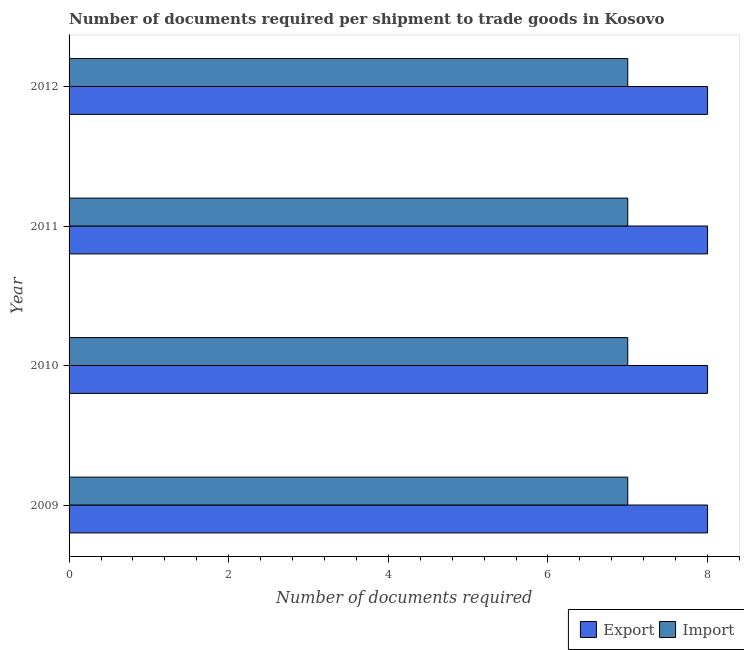How many bars are there on the 4th tick from the top?
Provide a succinct answer. 2. In how many cases, is the number of bars for a given year not equal to the number of legend labels?
Give a very brief answer. 0. What is the number of documents required to import goods in 2010?
Make the answer very short. 7. Across all years, what is the maximum number of documents required to export goods?
Ensure brevity in your answer.  8. Across all years, what is the minimum number of documents required to export goods?
Keep it short and to the point. 8. What is the total number of documents required to export goods in the graph?
Your answer should be compact. 32. What is the difference between the number of documents required to export goods in 2011 and that in 2012?
Give a very brief answer. 0. What is the difference between the number of documents required to export goods in 2010 and the number of documents required to import goods in 2012?
Offer a very short reply. 1. What is the average number of documents required to import goods per year?
Ensure brevity in your answer.  7. In the year 2012, what is the difference between the number of documents required to export goods and number of documents required to import goods?
Offer a very short reply. 1. What is the difference between the highest and the second highest number of documents required to import goods?
Your answer should be compact. 0. What is the difference between the highest and the lowest number of documents required to import goods?
Offer a terse response. 0. In how many years, is the number of documents required to import goods greater than the average number of documents required to import goods taken over all years?
Ensure brevity in your answer.  0. Is the sum of the number of documents required to import goods in 2011 and 2012 greater than the maximum number of documents required to export goods across all years?
Give a very brief answer. Yes. What does the 1st bar from the top in 2010 represents?
Your response must be concise. Import. What does the 2nd bar from the bottom in 2009 represents?
Provide a short and direct response. Import. How many bars are there?
Your response must be concise. 8. Are all the bars in the graph horizontal?
Provide a succinct answer. Yes. Does the graph contain any zero values?
Offer a very short reply. No. Does the graph contain grids?
Your answer should be compact. No. How many legend labels are there?
Keep it short and to the point. 2. How are the legend labels stacked?
Offer a terse response. Horizontal. What is the title of the graph?
Ensure brevity in your answer.  Number of documents required per shipment to trade goods in Kosovo. What is the label or title of the X-axis?
Provide a succinct answer. Number of documents required. What is the label or title of the Y-axis?
Your response must be concise. Year. What is the Number of documents required in Export in 2010?
Offer a very short reply. 8. What is the Number of documents required in Export in 2011?
Make the answer very short. 8. What is the Number of documents required of Import in 2012?
Provide a succinct answer. 7. What is the difference between the Number of documents required of Import in 2009 and that in 2011?
Your response must be concise. 0. What is the difference between the Number of documents required in Export in 2010 and that in 2011?
Keep it short and to the point. 0. What is the difference between the Number of documents required in Import in 2010 and that in 2011?
Your answer should be compact. 0. What is the difference between the Number of documents required of Export in 2011 and that in 2012?
Ensure brevity in your answer.  0. What is the difference between the Number of documents required of Export in 2009 and the Number of documents required of Import in 2010?
Provide a short and direct response. 1. What is the difference between the Number of documents required of Export in 2009 and the Number of documents required of Import in 2012?
Give a very brief answer. 1. What is the difference between the Number of documents required of Export in 2010 and the Number of documents required of Import in 2012?
Provide a succinct answer. 1. What is the difference between the Number of documents required of Export in 2011 and the Number of documents required of Import in 2012?
Keep it short and to the point. 1. What is the average Number of documents required of Export per year?
Your answer should be compact. 8. What is the average Number of documents required in Import per year?
Your answer should be very brief. 7. In the year 2011, what is the difference between the Number of documents required of Export and Number of documents required of Import?
Provide a short and direct response. 1. What is the ratio of the Number of documents required in Export in 2009 to that in 2010?
Offer a very short reply. 1. What is the ratio of the Number of documents required in Import in 2009 to that in 2010?
Offer a terse response. 1. What is the ratio of the Number of documents required in Import in 2009 to that in 2011?
Keep it short and to the point. 1. What is the ratio of the Number of documents required of Export in 2009 to that in 2012?
Provide a succinct answer. 1. What is the ratio of the Number of documents required in Import in 2009 to that in 2012?
Your response must be concise. 1. What is the ratio of the Number of documents required in Export in 2010 to that in 2011?
Give a very brief answer. 1. What is the ratio of the Number of documents required of Export in 2010 to that in 2012?
Keep it short and to the point. 1. What is the ratio of the Number of documents required in Export in 2011 to that in 2012?
Provide a short and direct response. 1. What is the ratio of the Number of documents required of Import in 2011 to that in 2012?
Provide a succinct answer. 1. What is the difference between the highest and the second highest Number of documents required of Export?
Your response must be concise. 0. What is the difference between the highest and the second highest Number of documents required in Import?
Offer a very short reply. 0. 